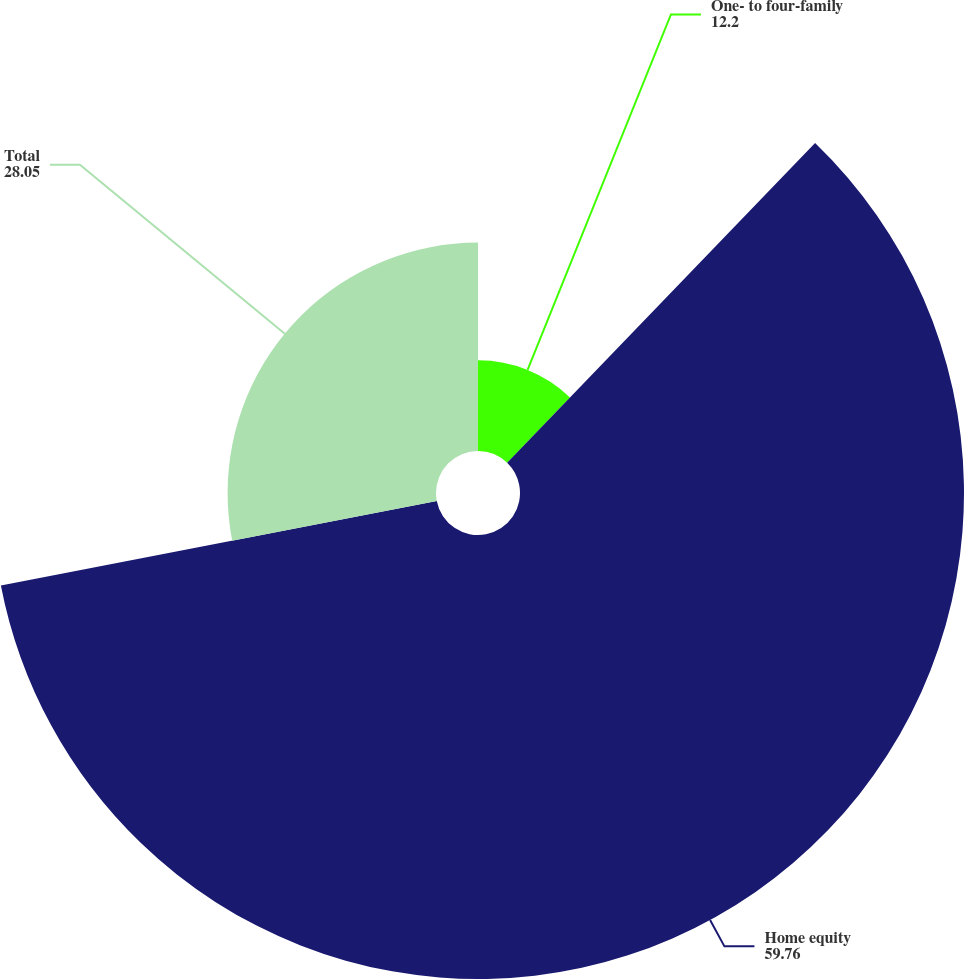<chart> <loc_0><loc_0><loc_500><loc_500><pie_chart><fcel>One- to four-family<fcel>Home equity<fcel>Total<nl><fcel>12.2%<fcel>59.76%<fcel>28.05%<nl></chart> 